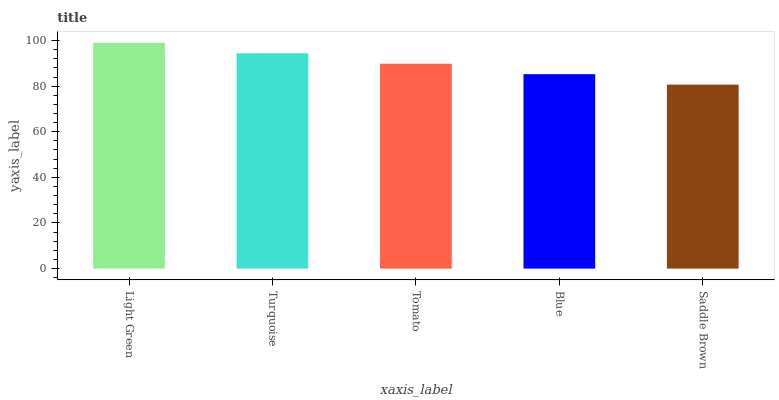Is Turquoise the minimum?
Answer yes or no. No. Is Turquoise the maximum?
Answer yes or no. No. Is Light Green greater than Turquoise?
Answer yes or no. Yes. Is Turquoise less than Light Green?
Answer yes or no. Yes. Is Turquoise greater than Light Green?
Answer yes or no. No. Is Light Green less than Turquoise?
Answer yes or no. No. Is Tomato the high median?
Answer yes or no. Yes. Is Tomato the low median?
Answer yes or no. Yes. Is Saddle Brown the high median?
Answer yes or no. No. Is Blue the low median?
Answer yes or no. No. 